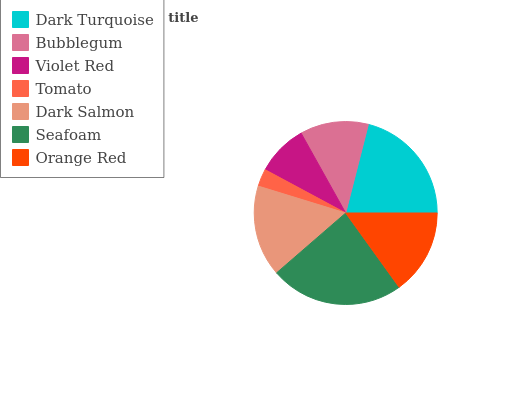Is Tomato the minimum?
Answer yes or no. Yes. Is Seafoam the maximum?
Answer yes or no. Yes. Is Bubblegum the minimum?
Answer yes or no. No. Is Bubblegum the maximum?
Answer yes or no. No. Is Dark Turquoise greater than Bubblegum?
Answer yes or no. Yes. Is Bubblegum less than Dark Turquoise?
Answer yes or no. Yes. Is Bubblegum greater than Dark Turquoise?
Answer yes or no. No. Is Dark Turquoise less than Bubblegum?
Answer yes or no. No. Is Orange Red the high median?
Answer yes or no. Yes. Is Orange Red the low median?
Answer yes or no. Yes. Is Dark Turquoise the high median?
Answer yes or no. No. Is Violet Red the low median?
Answer yes or no. No. 